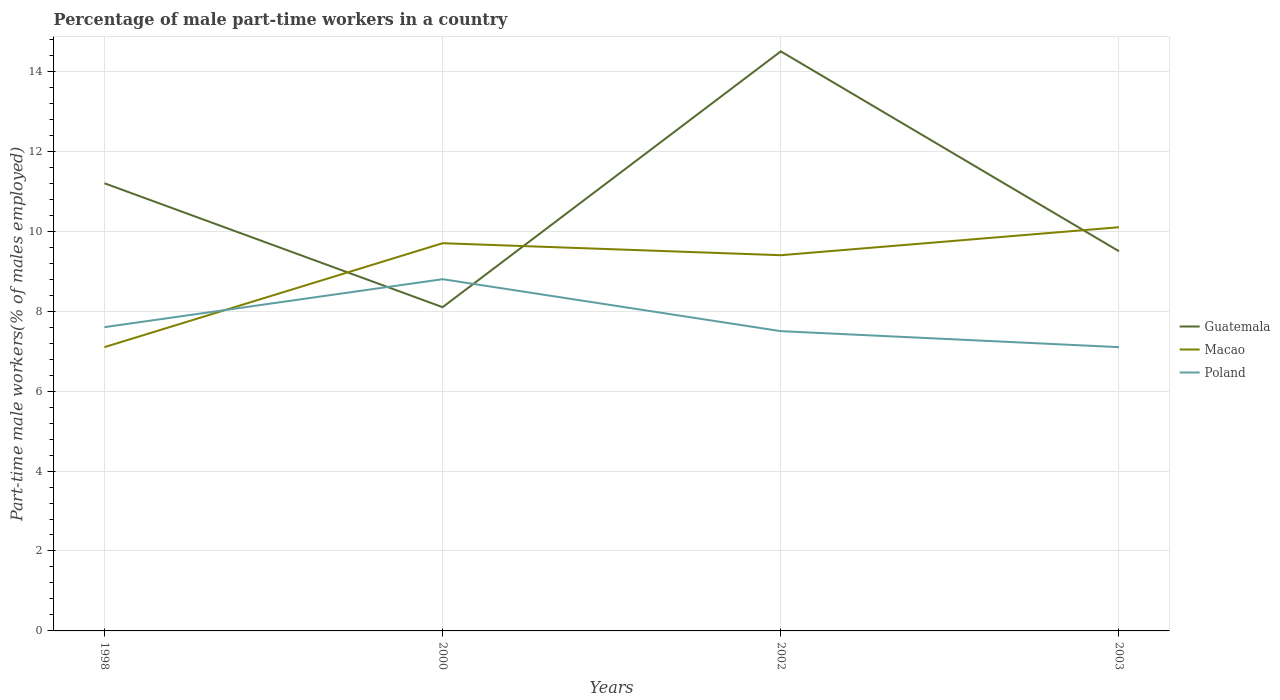Does the line corresponding to Poland intersect with the line corresponding to Macao?
Your answer should be compact. Yes. Is the number of lines equal to the number of legend labels?
Offer a terse response. Yes. Across all years, what is the maximum percentage of male part-time workers in Poland?
Offer a very short reply. 7.1. What is the total percentage of male part-time workers in Poland in the graph?
Provide a succinct answer. -1.2. What is the difference between the highest and the second highest percentage of male part-time workers in Macao?
Make the answer very short. 3. Is the percentage of male part-time workers in Poland strictly greater than the percentage of male part-time workers in Guatemala over the years?
Give a very brief answer. No. How many lines are there?
Provide a short and direct response. 3. How many years are there in the graph?
Your answer should be very brief. 4. Are the values on the major ticks of Y-axis written in scientific E-notation?
Make the answer very short. No. Where does the legend appear in the graph?
Your answer should be very brief. Center right. What is the title of the graph?
Your response must be concise. Percentage of male part-time workers in a country. What is the label or title of the Y-axis?
Your answer should be very brief. Part-time male workers(% of males employed). What is the Part-time male workers(% of males employed) of Guatemala in 1998?
Your response must be concise. 11.2. What is the Part-time male workers(% of males employed) in Macao in 1998?
Provide a short and direct response. 7.1. What is the Part-time male workers(% of males employed) in Poland in 1998?
Make the answer very short. 7.6. What is the Part-time male workers(% of males employed) in Guatemala in 2000?
Your response must be concise. 8.1. What is the Part-time male workers(% of males employed) in Macao in 2000?
Make the answer very short. 9.7. What is the Part-time male workers(% of males employed) of Poland in 2000?
Ensure brevity in your answer.  8.8. What is the Part-time male workers(% of males employed) in Guatemala in 2002?
Ensure brevity in your answer.  14.5. What is the Part-time male workers(% of males employed) of Macao in 2002?
Offer a terse response. 9.4. What is the Part-time male workers(% of males employed) of Macao in 2003?
Keep it short and to the point. 10.1. What is the Part-time male workers(% of males employed) of Poland in 2003?
Offer a terse response. 7.1. Across all years, what is the maximum Part-time male workers(% of males employed) in Macao?
Keep it short and to the point. 10.1. Across all years, what is the maximum Part-time male workers(% of males employed) of Poland?
Offer a very short reply. 8.8. Across all years, what is the minimum Part-time male workers(% of males employed) of Guatemala?
Provide a short and direct response. 8.1. Across all years, what is the minimum Part-time male workers(% of males employed) in Macao?
Give a very brief answer. 7.1. Across all years, what is the minimum Part-time male workers(% of males employed) of Poland?
Your answer should be very brief. 7.1. What is the total Part-time male workers(% of males employed) in Guatemala in the graph?
Keep it short and to the point. 43.3. What is the total Part-time male workers(% of males employed) of Macao in the graph?
Give a very brief answer. 36.3. What is the difference between the Part-time male workers(% of males employed) of Guatemala in 1998 and that in 2000?
Your response must be concise. 3.1. What is the difference between the Part-time male workers(% of males employed) of Macao in 1998 and that in 2000?
Your answer should be very brief. -2.6. What is the difference between the Part-time male workers(% of males employed) in Poland in 1998 and that in 2000?
Offer a very short reply. -1.2. What is the difference between the Part-time male workers(% of males employed) in Poland in 1998 and that in 2002?
Your response must be concise. 0.1. What is the difference between the Part-time male workers(% of males employed) in Guatemala in 1998 and that in 2003?
Your answer should be very brief. 1.7. What is the difference between the Part-time male workers(% of males employed) in Macao in 1998 and that in 2003?
Make the answer very short. -3. What is the difference between the Part-time male workers(% of males employed) in Macao in 2000 and that in 2002?
Give a very brief answer. 0.3. What is the difference between the Part-time male workers(% of males employed) of Guatemala in 2000 and that in 2003?
Offer a terse response. -1.4. What is the difference between the Part-time male workers(% of males employed) in Macao in 2000 and that in 2003?
Provide a succinct answer. -0.4. What is the difference between the Part-time male workers(% of males employed) in Poland in 2002 and that in 2003?
Give a very brief answer. 0.4. What is the difference between the Part-time male workers(% of males employed) in Guatemala in 1998 and the Part-time male workers(% of males employed) in Macao in 2000?
Your answer should be very brief. 1.5. What is the difference between the Part-time male workers(% of males employed) of Guatemala in 1998 and the Part-time male workers(% of males employed) of Macao in 2002?
Ensure brevity in your answer.  1.8. What is the difference between the Part-time male workers(% of males employed) in Guatemala in 1998 and the Part-time male workers(% of males employed) in Poland in 2003?
Ensure brevity in your answer.  4.1. What is the difference between the Part-time male workers(% of males employed) of Macao in 1998 and the Part-time male workers(% of males employed) of Poland in 2003?
Give a very brief answer. 0. What is the difference between the Part-time male workers(% of males employed) in Guatemala in 2000 and the Part-time male workers(% of males employed) in Poland in 2002?
Your answer should be compact. 0.6. What is the difference between the Part-time male workers(% of males employed) in Macao in 2000 and the Part-time male workers(% of males employed) in Poland in 2002?
Ensure brevity in your answer.  2.2. What is the difference between the Part-time male workers(% of males employed) of Guatemala in 2000 and the Part-time male workers(% of males employed) of Poland in 2003?
Provide a short and direct response. 1. What is the difference between the Part-time male workers(% of males employed) of Guatemala in 2002 and the Part-time male workers(% of males employed) of Macao in 2003?
Offer a terse response. 4.4. What is the average Part-time male workers(% of males employed) of Guatemala per year?
Your answer should be very brief. 10.82. What is the average Part-time male workers(% of males employed) in Macao per year?
Give a very brief answer. 9.07. What is the average Part-time male workers(% of males employed) in Poland per year?
Keep it short and to the point. 7.75. In the year 1998, what is the difference between the Part-time male workers(% of males employed) in Guatemala and Part-time male workers(% of males employed) in Macao?
Provide a succinct answer. 4.1. In the year 2000, what is the difference between the Part-time male workers(% of males employed) of Guatemala and Part-time male workers(% of males employed) of Poland?
Provide a short and direct response. -0.7. In the year 2003, what is the difference between the Part-time male workers(% of males employed) in Guatemala and Part-time male workers(% of males employed) in Macao?
Make the answer very short. -0.6. In the year 2003, what is the difference between the Part-time male workers(% of males employed) of Guatemala and Part-time male workers(% of males employed) of Poland?
Offer a very short reply. 2.4. In the year 2003, what is the difference between the Part-time male workers(% of males employed) of Macao and Part-time male workers(% of males employed) of Poland?
Ensure brevity in your answer.  3. What is the ratio of the Part-time male workers(% of males employed) in Guatemala in 1998 to that in 2000?
Make the answer very short. 1.38. What is the ratio of the Part-time male workers(% of males employed) of Macao in 1998 to that in 2000?
Ensure brevity in your answer.  0.73. What is the ratio of the Part-time male workers(% of males employed) of Poland in 1998 to that in 2000?
Provide a succinct answer. 0.86. What is the ratio of the Part-time male workers(% of males employed) in Guatemala in 1998 to that in 2002?
Ensure brevity in your answer.  0.77. What is the ratio of the Part-time male workers(% of males employed) in Macao in 1998 to that in 2002?
Ensure brevity in your answer.  0.76. What is the ratio of the Part-time male workers(% of males employed) of Poland in 1998 to that in 2002?
Provide a succinct answer. 1.01. What is the ratio of the Part-time male workers(% of males employed) in Guatemala in 1998 to that in 2003?
Provide a succinct answer. 1.18. What is the ratio of the Part-time male workers(% of males employed) of Macao in 1998 to that in 2003?
Provide a short and direct response. 0.7. What is the ratio of the Part-time male workers(% of males employed) of Poland in 1998 to that in 2003?
Make the answer very short. 1.07. What is the ratio of the Part-time male workers(% of males employed) in Guatemala in 2000 to that in 2002?
Offer a very short reply. 0.56. What is the ratio of the Part-time male workers(% of males employed) of Macao in 2000 to that in 2002?
Offer a very short reply. 1.03. What is the ratio of the Part-time male workers(% of males employed) in Poland in 2000 to that in 2002?
Your response must be concise. 1.17. What is the ratio of the Part-time male workers(% of males employed) of Guatemala in 2000 to that in 2003?
Ensure brevity in your answer.  0.85. What is the ratio of the Part-time male workers(% of males employed) in Macao in 2000 to that in 2003?
Give a very brief answer. 0.96. What is the ratio of the Part-time male workers(% of males employed) in Poland in 2000 to that in 2003?
Offer a very short reply. 1.24. What is the ratio of the Part-time male workers(% of males employed) of Guatemala in 2002 to that in 2003?
Keep it short and to the point. 1.53. What is the ratio of the Part-time male workers(% of males employed) of Macao in 2002 to that in 2003?
Your answer should be very brief. 0.93. What is the ratio of the Part-time male workers(% of males employed) of Poland in 2002 to that in 2003?
Your answer should be compact. 1.06. What is the difference between the highest and the lowest Part-time male workers(% of males employed) of Guatemala?
Your response must be concise. 6.4. What is the difference between the highest and the lowest Part-time male workers(% of males employed) in Macao?
Provide a succinct answer. 3. 